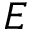<formula> <loc_0><loc_0><loc_500><loc_500>E</formula> 